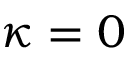<formula> <loc_0><loc_0><loc_500><loc_500>\kappa = 0</formula> 